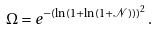Convert formula to latex. <formula><loc_0><loc_0><loc_500><loc_500>\Omega = e ^ { - \left ( \ln ( 1 + \ln ( 1 + \mathcal { N } ) ) \right ) ^ { 2 } } \, .</formula> 